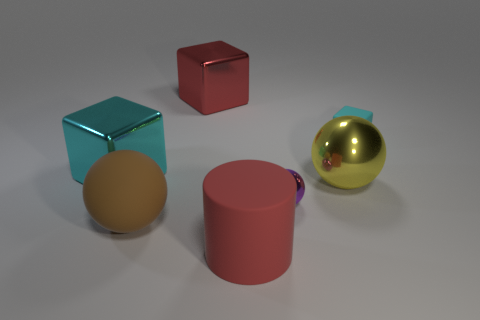Subtract all yellow cylinders. Subtract all cyan balls. How many cylinders are left? 1 Add 1 small spheres. How many objects exist? 8 Subtract all cubes. How many objects are left? 4 Add 2 tiny purple balls. How many tiny purple balls exist? 3 Subtract 1 yellow balls. How many objects are left? 6 Subtract all red shiny blocks. Subtract all small rubber things. How many objects are left? 5 Add 5 matte objects. How many matte objects are left? 8 